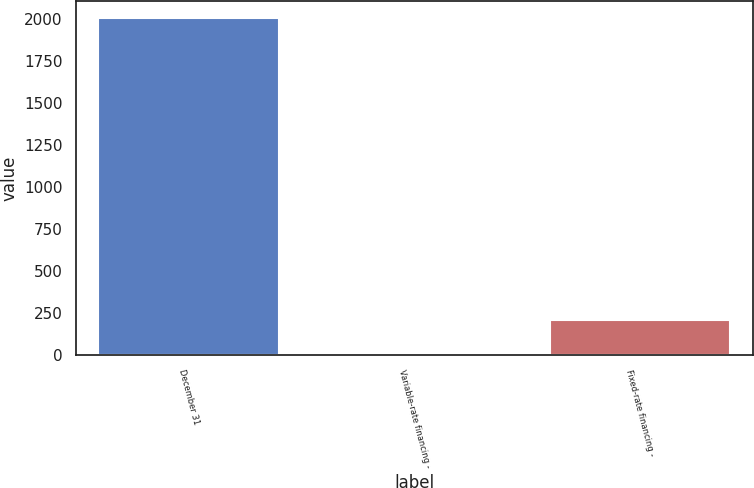Convert chart to OTSL. <chart><loc_0><loc_0><loc_500><loc_500><bar_chart><fcel>December 31<fcel>Variable-rate financing -<fcel>Fixed-rate financing -<nl><fcel>2008<fcel>1<fcel>208<nl></chart> 